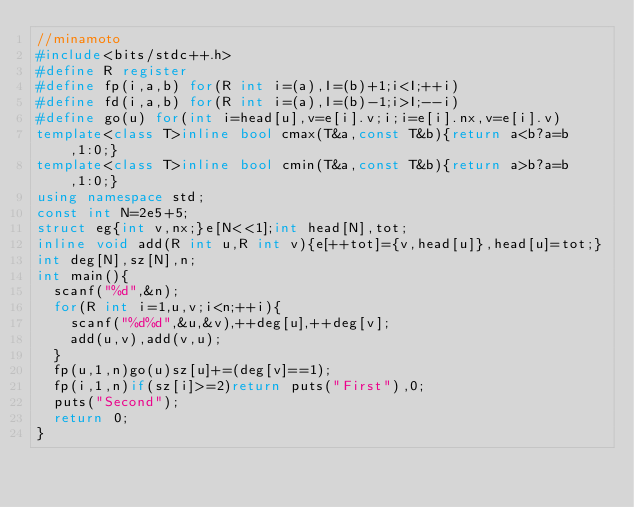Convert code to text. <code><loc_0><loc_0><loc_500><loc_500><_C++_>//minamoto
#include<bits/stdc++.h>
#define R register
#define fp(i,a,b) for(R int i=(a),I=(b)+1;i<I;++i)
#define fd(i,a,b) for(R int i=(a),I=(b)-1;i>I;--i)
#define go(u) for(int i=head[u],v=e[i].v;i;i=e[i].nx,v=e[i].v)
template<class T>inline bool cmax(T&a,const T&b){return a<b?a=b,1:0;}
template<class T>inline bool cmin(T&a,const T&b){return a>b?a=b,1:0;}
using namespace std;
const int N=2e5+5;
struct eg{int v,nx;}e[N<<1];int head[N],tot;
inline void add(R int u,R int v){e[++tot]={v,head[u]},head[u]=tot;}
int deg[N],sz[N],n;
int main(){
	scanf("%d",&n);
	for(R int i=1,u,v;i<n;++i){
		scanf("%d%d",&u,&v),++deg[u],++deg[v];
		add(u,v),add(v,u);
	}
	fp(u,1,n)go(u)sz[u]+=(deg[v]==1);
	fp(i,1,n)if(sz[i]>=2)return puts("First"),0;
	puts("Second");
	return 0;
}</code> 